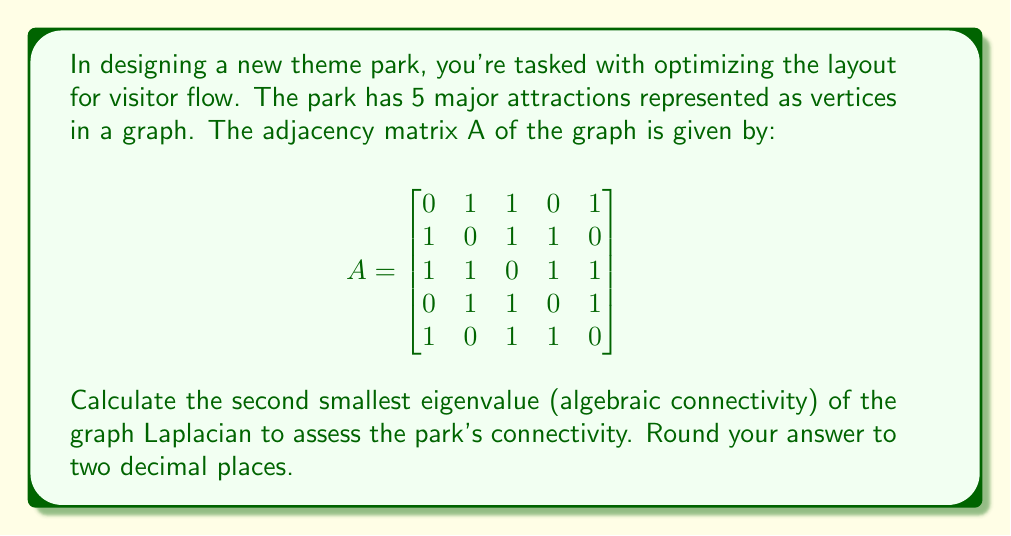Can you answer this question? To solve this problem, we'll follow these steps:

1) First, we need to calculate the degree matrix D. The degree of each vertex is the sum of its row in the adjacency matrix:

   $$D = \begin{bmatrix}
   3 & 0 & 0 & 0 & 0 \\
   0 & 3 & 0 & 0 & 0 \\
   0 & 0 & 4 & 0 & 0 \\
   0 & 0 & 0 & 3 & 0 \\
   0 & 0 & 0 & 0 & 3
   \end{bmatrix}$$

2) Now, we can calculate the Laplacian matrix L = D - A:

   $$L = D - A = \begin{bmatrix}
   3 & -1 & -1 & 0 & -1 \\
   -1 & 3 & -1 & -1 & 0 \\
   -1 & -1 & 4 & -1 & -1 \\
   0 & -1 & -1 & 3 & -1 \\
   -1 & 0 & -1 & -1 & 3
   \end{bmatrix}$$

3) To find the eigenvalues of L, we need to solve the characteristic equation:

   $$det(L - \lambda I) = 0$$

4) Solving this equation (which is a 5th degree polynomial) is complex, so we'd typically use numerical methods or software. The eigenvalues are approximately:

   $\lambda_1 = 0$
   $\lambda_2 = 1.382$
   $\lambda_3 = 3$
   $\lambda_4 = 4$
   $\lambda_5 = 5.618$

5) The second smallest eigenvalue (algebraic connectivity) is $\lambda_2 = 1.382$.

6) Rounding to two decimal places, we get 1.38.

This value indicates moderate connectivity in the park layout. Higher values (closer to the number of vertices) would indicate better connectivity and potentially more efficient visitor flow.
Answer: 1.38 